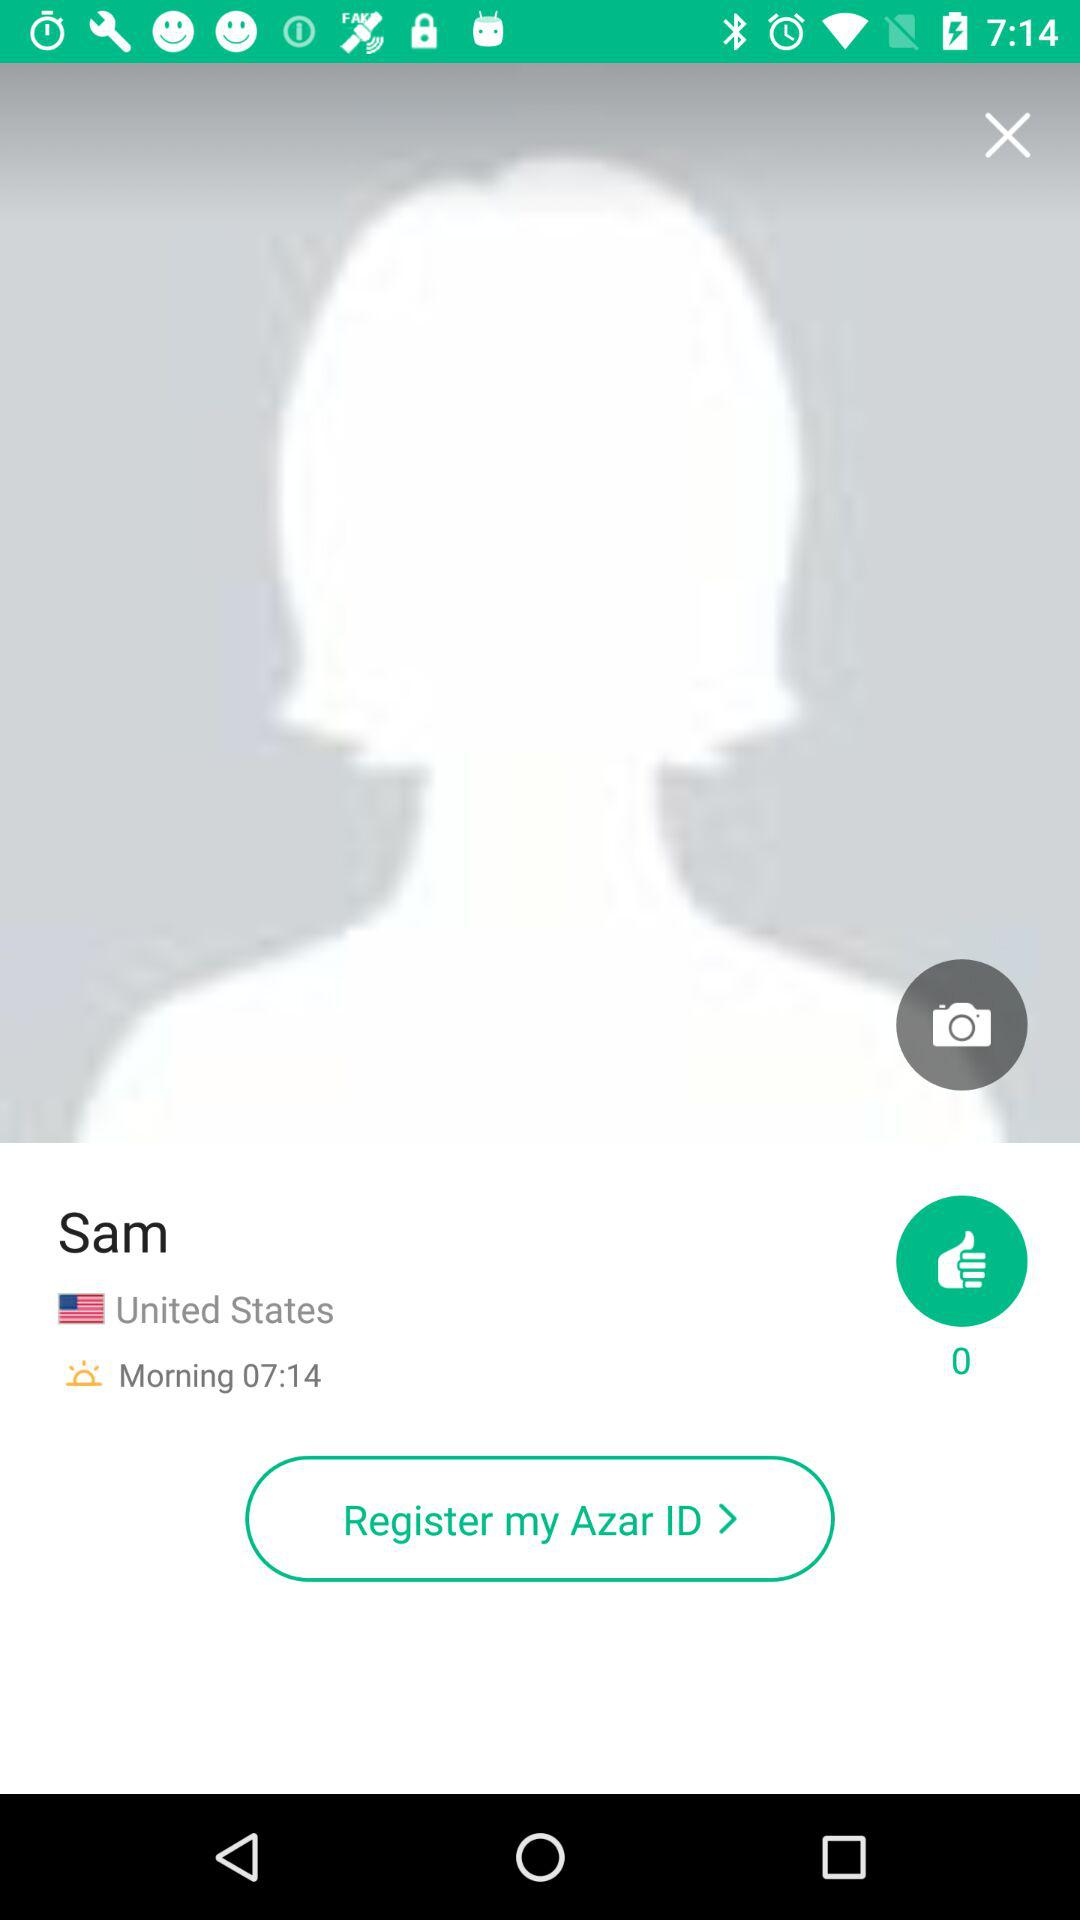What is the user's location? The user's location is the United States. 